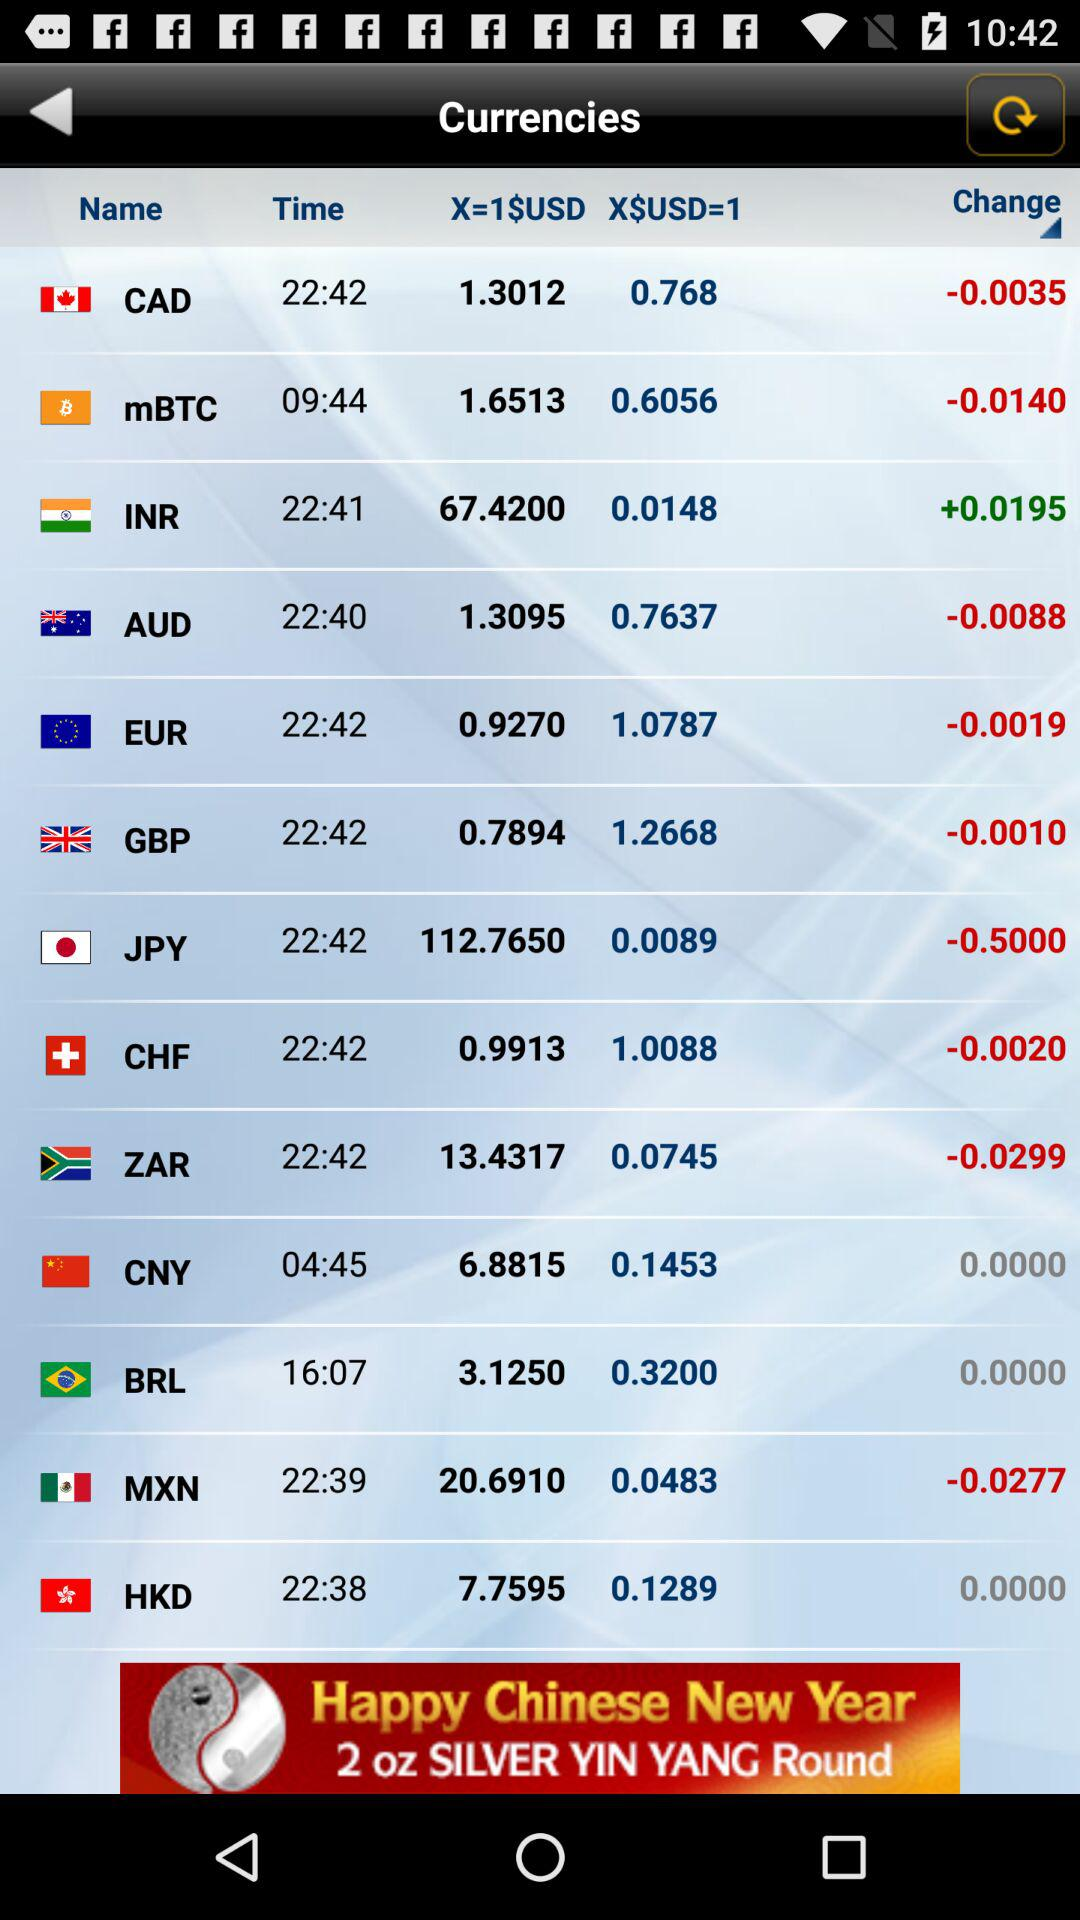What is the value of 1 USD in CAD? The value of 1 USD in CAD is 1.3012. 